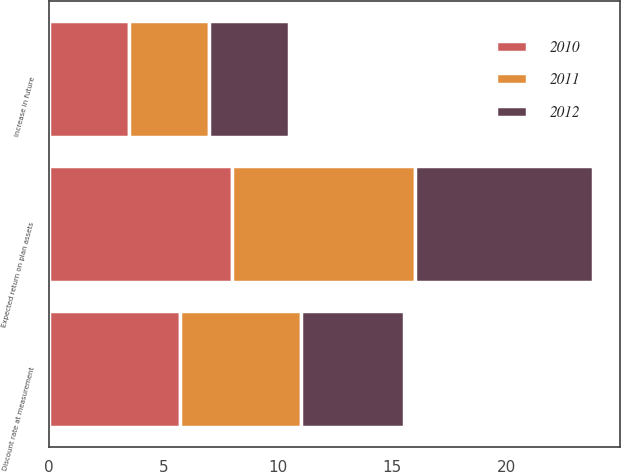<chart> <loc_0><loc_0><loc_500><loc_500><stacked_bar_chart><ecel><fcel>Discount rate at measurement<fcel>Expected return on plan assets<fcel>Increase in future<nl><fcel>2012<fcel>4.5<fcel>7.75<fcel>3.5<nl><fcel>2011<fcel>5.25<fcel>8<fcel>3.5<nl><fcel>2010<fcel>5.75<fcel>8<fcel>3.5<nl></chart> 